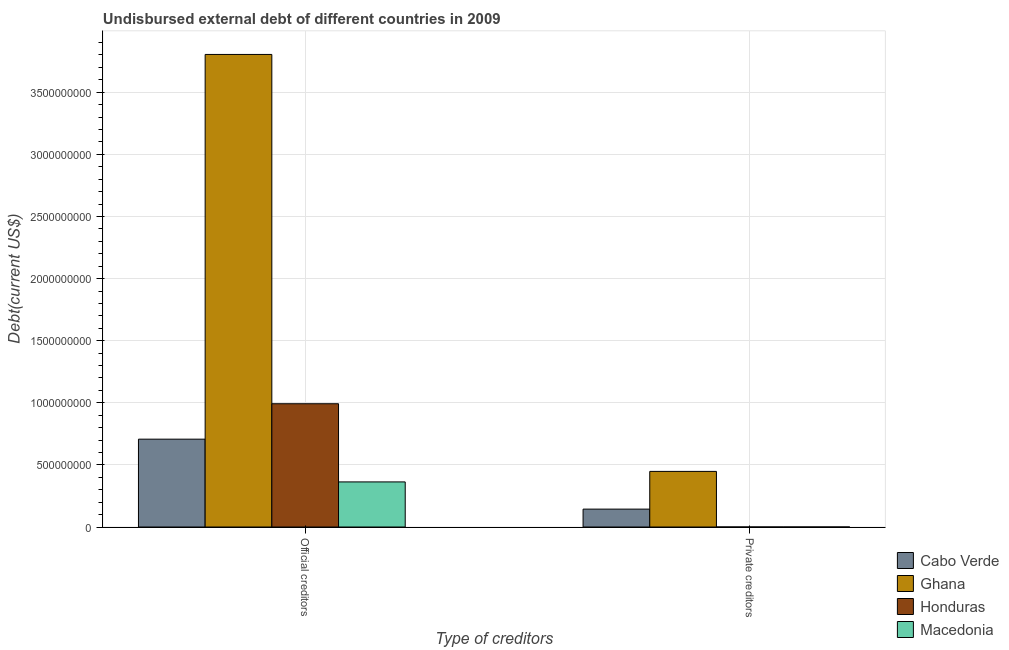How many different coloured bars are there?
Make the answer very short. 4. How many bars are there on the 2nd tick from the right?
Keep it short and to the point. 4. What is the label of the 1st group of bars from the left?
Ensure brevity in your answer.  Official creditors. What is the undisbursed external debt of private creditors in Macedonia?
Your answer should be very brief. 9.90e+04. Across all countries, what is the maximum undisbursed external debt of private creditors?
Give a very brief answer. 4.48e+08. Across all countries, what is the minimum undisbursed external debt of private creditors?
Offer a terse response. 9.90e+04. In which country was the undisbursed external debt of official creditors maximum?
Provide a succinct answer. Ghana. In which country was the undisbursed external debt of private creditors minimum?
Provide a succinct answer. Macedonia. What is the total undisbursed external debt of official creditors in the graph?
Offer a very short reply. 5.87e+09. What is the difference between the undisbursed external debt of private creditors in Honduras and that in Cabo Verde?
Keep it short and to the point. -1.44e+08. What is the difference between the undisbursed external debt of official creditors in Macedonia and the undisbursed external debt of private creditors in Honduras?
Offer a terse response. 3.63e+08. What is the average undisbursed external debt of private creditors per country?
Ensure brevity in your answer.  1.48e+08. What is the difference between the undisbursed external debt of private creditors and undisbursed external debt of official creditors in Ghana?
Your answer should be compact. -3.36e+09. In how many countries, is the undisbursed external debt of official creditors greater than 1600000000 US$?
Keep it short and to the point. 1. What is the ratio of the undisbursed external debt of official creditors in Macedonia to that in Honduras?
Make the answer very short. 0.37. Is the undisbursed external debt of private creditors in Cabo Verde less than that in Honduras?
Give a very brief answer. No. What does the 4th bar from the left in Official creditors represents?
Make the answer very short. Macedonia. What does the 1st bar from the right in Official creditors represents?
Your response must be concise. Macedonia. What is the difference between two consecutive major ticks on the Y-axis?
Make the answer very short. 5.00e+08. Are the values on the major ticks of Y-axis written in scientific E-notation?
Keep it short and to the point. No. Does the graph contain any zero values?
Your answer should be compact. No. Does the graph contain grids?
Make the answer very short. Yes. Where does the legend appear in the graph?
Make the answer very short. Bottom right. How many legend labels are there?
Your answer should be very brief. 4. What is the title of the graph?
Your answer should be compact. Undisbursed external debt of different countries in 2009. Does "Albania" appear as one of the legend labels in the graph?
Give a very brief answer. No. What is the label or title of the X-axis?
Make the answer very short. Type of creditors. What is the label or title of the Y-axis?
Provide a succinct answer. Debt(current US$). What is the Debt(current US$) of Cabo Verde in Official creditors?
Your answer should be compact. 7.07e+08. What is the Debt(current US$) of Ghana in Official creditors?
Give a very brief answer. 3.80e+09. What is the Debt(current US$) of Honduras in Official creditors?
Your response must be concise. 9.92e+08. What is the Debt(current US$) of Macedonia in Official creditors?
Keep it short and to the point. 3.63e+08. What is the Debt(current US$) in Cabo Verde in Private creditors?
Your answer should be very brief. 1.44e+08. What is the Debt(current US$) of Ghana in Private creditors?
Keep it short and to the point. 4.48e+08. What is the Debt(current US$) of Honduras in Private creditors?
Your answer should be compact. 1.32e+05. What is the Debt(current US$) in Macedonia in Private creditors?
Make the answer very short. 9.90e+04. Across all Type of creditors, what is the maximum Debt(current US$) in Cabo Verde?
Your answer should be very brief. 7.07e+08. Across all Type of creditors, what is the maximum Debt(current US$) of Ghana?
Provide a short and direct response. 3.80e+09. Across all Type of creditors, what is the maximum Debt(current US$) of Honduras?
Give a very brief answer. 9.92e+08. Across all Type of creditors, what is the maximum Debt(current US$) in Macedonia?
Make the answer very short. 3.63e+08. Across all Type of creditors, what is the minimum Debt(current US$) in Cabo Verde?
Keep it short and to the point. 1.44e+08. Across all Type of creditors, what is the minimum Debt(current US$) of Ghana?
Offer a terse response. 4.48e+08. Across all Type of creditors, what is the minimum Debt(current US$) of Honduras?
Keep it short and to the point. 1.32e+05. Across all Type of creditors, what is the minimum Debt(current US$) in Macedonia?
Keep it short and to the point. 9.90e+04. What is the total Debt(current US$) in Cabo Verde in the graph?
Offer a very short reply. 8.51e+08. What is the total Debt(current US$) of Ghana in the graph?
Ensure brevity in your answer.  4.25e+09. What is the total Debt(current US$) of Honduras in the graph?
Keep it short and to the point. 9.92e+08. What is the total Debt(current US$) of Macedonia in the graph?
Provide a succinct answer. 3.63e+08. What is the difference between the Debt(current US$) in Cabo Verde in Official creditors and that in Private creditors?
Keep it short and to the point. 5.63e+08. What is the difference between the Debt(current US$) in Ghana in Official creditors and that in Private creditors?
Your answer should be very brief. 3.36e+09. What is the difference between the Debt(current US$) of Honduras in Official creditors and that in Private creditors?
Your answer should be compact. 9.92e+08. What is the difference between the Debt(current US$) of Macedonia in Official creditors and that in Private creditors?
Make the answer very short. 3.63e+08. What is the difference between the Debt(current US$) of Cabo Verde in Official creditors and the Debt(current US$) of Ghana in Private creditors?
Provide a succinct answer. 2.59e+08. What is the difference between the Debt(current US$) of Cabo Verde in Official creditors and the Debt(current US$) of Honduras in Private creditors?
Offer a terse response. 7.07e+08. What is the difference between the Debt(current US$) in Cabo Verde in Official creditors and the Debt(current US$) in Macedonia in Private creditors?
Provide a short and direct response. 7.07e+08. What is the difference between the Debt(current US$) of Ghana in Official creditors and the Debt(current US$) of Honduras in Private creditors?
Provide a succinct answer. 3.80e+09. What is the difference between the Debt(current US$) in Ghana in Official creditors and the Debt(current US$) in Macedonia in Private creditors?
Offer a very short reply. 3.80e+09. What is the difference between the Debt(current US$) in Honduras in Official creditors and the Debt(current US$) in Macedonia in Private creditors?
Provide a short and direct response. 9.92e+08. What is the average Debt(current US$) of Cabo Verde per Type of creditors?
Keep it short and to the point. 4.26e+08. What is the average Debt(current US$) of Ghana per Type of creditors?
Provide a succinct answer. 2.13e+09. What is the average Debt(current US$) of Honduras per Type of creditors?
Make the answer very short. 4.96e+08. What is the average Debt(current US$) of Macedonia per Type of creditors?
Give a very brief answer. 1.82e+08. What is the difference between the Debt(current US$) of Cabo Verde and Debt(current US$) of Ghana in Official creditors?
Your response must be concise. -3.10e+09. What is the difference between the Debt(current US$) in Cabo Verde and Debt(current US$) in Honduras in Official creditors?
Your answer should be compact. -2.85e+08. What is the difference between the Debt(current US$) in Cabo Verde and Debt(current US$) in Macedonia in Official creditors?
Provide a short and direct response. 3.44e+08. What is the difference between the Debt(current US$) of Ghana and Debt(current US$) of Honduras in Official creditors?
Offer a terse response. 2.81e+09. What is the difference between the Debt(current US$) of Ghana and Debt(current US$) of Macedonia in Official creditors?
Provide a succinct answer. 3.44e+09. What is the difference between the Debt(current US$) of Honduras and Debt(current US$) of Macedonia in Official creditors?
Provide a succinct answer. 6.29e+08. What is the difference between the Debt(current US$) of Cabo Verde and Debt(current US$) of Ghana in Private creditors?
Provide a succinct answer. -3.04e+08. What is the difference between the Debt(current US$) in Cabo Verde and Debt(current US$) in Honduras in Private creditors?
Your answer should be very brief. 1.44e+08. What is the difference between the Debt(current US$) in Cabo Verde and Debt(current US$) in Macedonia in Private creditors?
Provide a short and direct response. 1.44e+08. What is the difference between the Debt(current US$) of Ghana and Debt(current US$) of Honduras in Private creditors?
Your answer should be very brief. 4.48e+08. What is the difference between the Debt(current US$) of Ghana and Debt(current US$) of Macedonia in Private creditors?
Your answer should be compact. 4.48e+08. What is the difference between the Debt(current US$) of Honduras and Debt(current US$) of Macedonia in Private creditors?
Provide a short and direct response. 3.30e+04. What is the ratio of the Debt(current US$) of Cabo Verde in Official creditors to that in Private creditors?
Offer a terse response. 4.91. What is the ratio of the Debt(current US$) of Ghana in Official creditors to that in Private creditors?
Your answer should be very brief. 8.5. What is the ratio of the Debt(current US$) of Honduras in Official creditors to that in Private creditors?
Keep it short and to the point. 7517.68. What is the ratio of the Debt(current US$) in Macedonia in Official creditors to that in Private creditors?
Offer a very short reply. 3666.85. What is the difference between the highest and the second highest Debt(current US$) of Cabo Verde?
Give a very brief answer. 5.63e+08. What is the difference between the highest and the second highest Debt(current US$) of Ghana?
Your answer should be very brief. 3.36e+09. What is the difference between the highest and the second highest Debt(current US$) in Honduras?
Your response must be concise. 9.92e+08. What is the difference between the highest and the second highest Debt(current US$) of Macedonia?
Offer a very short reply. 3.63e+08. What is the difference between the highest and the lowest Debt(current US$) in Cabo Verde?
Your response must be concise. 5.63e+08. What is the difference between the highest and the lowest Debt(current US$) in Ghana?
Provide a short and direct response. 3.36e+09. What is the difference between the highest and the lowest Debt(current US$) in Honduras?
Provide a short and direct response. 9.92e+08. What is the difference between the highest and the lowest Debt(current US$) of Macedonia?
Ensure brevity in your answer.  3.63e+08. 